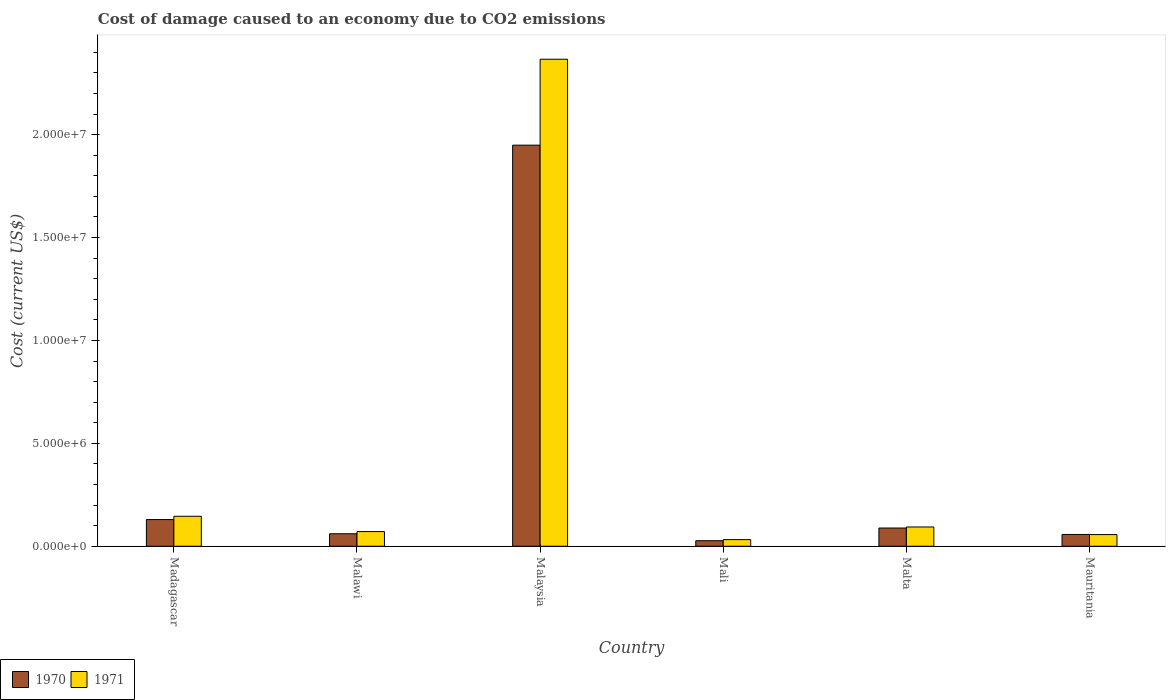How many groups of bars are there?
Ensure brevity in your answer.  6. Are the number of bars on each tick of the X-axis equal?
Your answer should be very brief. Yes. What is the label of the 5th group of bars from the left?
Your answer should be compact. Malta. In how many cases, is the number of bars for a given country not equal to the number of legend labels?
Provide a short and direct response. 0. What is the cost of damage caused due to CO2 emissisons in 1971 in Mali?
Offer a terse response. 3.23e+05. Across all countries, what is the maximum cost of damage caused due to CO2 emissisons in 1970?
Your response must be concise. 1.95e+07. Across all countries, what is the minimum cost of damage caused due to CO2 emissisons in 1970?
Ensure brevity in your answer.  2.69e+05. In which country was the cost of damage caused due to CO2 emissisons in 1971 maximum?
Ensure brevity in your answer.  Malaysia. In which country was the cost of damage caused due to CO2 emissisons in 1971 minimum?
Ensure brevity in your answer.  Mali. What is the total cost of damage caused due to CO2 emissisons in 1970 in the graph?
Ensure brevity in your answer.  2.31e+07. What is the difference between the cost of damage caused due to CO2 emissisons in 1970 in Madagascar and that in Mali?
Provide a short and direct response. 1.03e+06. What is the difference between the cost of damage caused due to CO2 emissisons in 1970 in Mauritania and the cost of damage caused due to CO2 emissisons in 1971 in Madagascar?
Make the answer very short. -8.84e+05. What is the average cost of damage caused due to CO2 emissisons in 1971 per country?
Your response must be concise. 4.61e+06. What is the difference between the cost of damage caused due to CO2 emissisons of/in 1971 and cost of damage caused due to CO2 emissisons of/in 1970 in Malta?
Provide a short and direct response. 5.07e+04. In how many countries, is the cost of damage caused due to CO2 emissisons in 1971 greater than 5000000 US$?
Give a very brief answer. 1. What is the ratio of the cost of damage caused due to CO2 emissisons in 1971 in Malawi to that in Malaysia?
Your response must be concise. 0.03. Is the cost of damage caused due to CO2 emissisons in 1970 in Malawi less than that in Mali?
Your response must be concise. No. Is the difference between the cost of damage caused due to CO2 emissisons in 1971 in Malaysia and Mauritania greater than the difference between the cost of damage caused due to CO2 emissisons in 1970 in Malaysia and Mauritania?
Provide a succinct answer. Yes. What is the difference between the highest and the second highest cost of damage caused due to CO2 emissisons in 1971?
Make the answer very short. -2.22e+07. What is the difference between the highest and the lowest cost of damage caused due to CO2 emissisons in 1970?
Your response must be concise. 1.92e+07. In how many countries, is the cost of damage caused due to CO2 emissisons in 1971 greater than the average cost of damage caused due to CO2 emissisons in 1971 taken over all countries?
Ensure brevity in your answer.  1. Is the sum of the cost of damage caused due to CO2 emissisons in 1971 in Mali and Malta greater than the maximum cost of damage caused due to CO2 emissisons in 1970 across all countries?
Your answer should be very brief. No. What does the 2nd bar from the left in Mauritania represents?
Provide a short and direct response. 1971. How many countries are there in the graph?
Give a very brief answer. 6. Are the values on the major ticks of Y-axis written in scientific E-notation?
Keep it short and to the point. Yes. Does the graph contain any zero values?
Offer a very short reply. No. How many legend labels are there?
Give a very brief answer. 2. How are the legend labels stacked?
Your answer should be very brief. Horizontal. What is the title of the graph?
Your answer should be compact. Cost of damage caused to an economy due to CO2 emissions. What is the label or title of the X-axis?
Your answer should be compact. Country. What is the label or title of the Y-axis?
Offer a very short reply. Cost (current US$). What is the Cost (current US$) in 1970 in Madagascar?
Give a very brief answer. 1.30e+06. What is the Cost (current US$) in 1971 in Madagascar?
Your answer should be compact. 1.46e+06. What is the Cost (current US$) in 1970 in Malawi?
Your response must be concise. 6.07e+05. What is the Cost (current US$) of 1971 in Malawi?
Your answer should be compact. 7.13e+05. What is the Cost (current US$) in 1970 in Malaysia?
Offer a very short reply. 1.95e+07. What is the Cost (current US$) of 1971 in Malaysia?
Keep it short and to the point. 2.37e+07. What is the Cost (current US$) in 1970 in Mali?
Offer a very short reply. 2.69e+05. What is the Cost (current US$) of 1971 in Mali?
Your answer should be very brief. 3.23e+05. What is the Cost (current US$) of 1970 in Malta?
Your answer should be very brief. 8.86e+05. What is the Cost (current US$) of 1971 in Malta?
Your answer should be very brief. 9.37e+05. What is the Cost (current US$) in 1970 in Mauritania?
Ensure brevity in your answer.  5.73e+05. What is the Cost (current US$) of 1971 in Mauritania?
Your answer should be compact. 5.67e+05. Across all countries, what is the maximum Cost (current US$) in 1970?
Your answer should be compact. 1.95e+07. Across all countries, what is the maximum Cost (current US$) in 1971?
Your answer should be very brief. 2.37e+07. Across all countries, what is the minimum Cost (current US$) of 1970?
Your response must be concise. 2.69e+05. Across all countries, what is the minimum Cost (current US$) of 1971?
Make the answer very short. 3.23e+05. What is the total Cost (current US$) of 1970 in the graph?
Offer a very short reply. 2.31e+07. What is the total Cost (current US$) in 1971 in the graph?
Your answer should be compact. 2.77e+07. What is the difference between the Cost (current US$) of 1970 in Madagascar and that in Malawi?
Your answer should be compact. 6.90e+05. What is the difference between the Cost (current US$) in 1971 in Madagascar and that in Malawi?
Provide a succinct answer. 7.44e+05. What is the difference between the Cost (current US$) of 1970 in Madagascar and that in Malaysia?
Make the answer very short. -1.82e+07. What is the difference between the Cost (current US$) in 1971 in Madagascar and that in Malaysia?
Your answer should be compact. -2.22e+07. What is the difference between the Cost (current US$) in 1970 in Madagascar and that in Mali?
Your answer should be very brief. 1.03e+06. What is the difference between the Cost (current US$) in 1971 in Madagascar and that in Mali?
Give a very brief answer. 1.13e+06. What is the difference between the Cost (current US$) of 1970 in Madagascar and that in Malta?
Keep it short and to the point. 4.11e+05. What is the difference between the Cost (current US$) in 1971 in Madagascar and that in Malta?
Provide a short and direct response. 5.20e+05. What is the difference between the Cost (current US$) of 1970 in Madagascar and that in Mauritania?
Give a very brief answer. 7.24e+05. What is the difference between the Cost (current US$) in 1971 in Madagascar and that in Mauritania?
Offer a very short reply. 8.90e+05. What is the difference between the Cost (current US$) in 1970 in Malawi and that in Malaysia?
Offer a very short reply. -1.89e+07. What is the difference between the Cost (current US$) in 1971 in Malawi and that in Malaysia?
Offer a very short reply. -2.30e+07. What is the difference between the Cost (current US$) of 1970 in Malawi and that in Mali?
Keep it short and to the point. 3.38e+05. What is the difference between the Cost (current US$) of 1971 in Malawi and that in Mali?
Provide a short and direct response. 3.90e+05. What is the difference between the Cost (current US$) of 1970 in Malawi and that in Malta?
Offer a very short reply. -2.79e+05. What is the difference between the Cost (current US$) in 1971 in Malawi and that in Malta?
Your response must be concise. -2.24e+05. What is the difference between the Cost (current US$) in 1970 in Malawi and that in Mauritania?
Give a very brief answer. 3.43e+04. What is the difference between the Cost (current US$) of 1971 in Malawi and that in Mauritania?
Provide a succinct answer. 1.46e+05. What is the difference between the Cost (current US$) of 1970 in Malaysia and that in Mali?
Offer a terse response. 1.92e+07. What is the difference between the Cost (current US$) in 1971 in Malaysia and that in Mali?
Your answer should be compact. 2.33e+07. What is the difference between the Cost (current US$) in 1970 in Malaysia and that in Malta?
Offer a very short reply. 1.86e+07. What is the difference between the Cost (current US$) of 1971 in Malaysia and that in Malta?
Keep it short and to the point. 2.27e+07. What is the difference between the Cost (current US$) in 1970 in Malaysia and that in Mauritania?
Offer a terse response. 1.89e+07. What is the difference between the Cost (current US$) in 1971 in Malaysia and that in Mauritania?
Make the answer very short. 2.31e+07. What is the difference between the Cost (current US$) of 1970 in Mali and that in Malta?
Your response must be concise. -6.17e+05. What is the difference between the Cost (current US$) in 1971 in Mali and that in Malta?
Give a very brief answer. -6.14e+05. What is the difference between the Cost (current US$) of 1970 in Mali and that in Mauritania?
Your answer should be very brief. -3.03e+05. What is the difference between the Cost (current US$) of 1971 in Mali and that in Mauritania?
Your answer should be compact. -2.45e+05. What is the difference between the Cost (current US$) in 1970 in Malta and that in Mauritania?
Provide a succinct answer. 3.13e+05. What is the difference between the Cost (current US$) of 1971 in Malta and that in Mauritania?
Offer a very short reply. 3.69e+05. What is the difference between the Cost (current US$) of 1970 in Madagascar and the Cost (current US$) of 1971 in Malawi?
Offer a terse response. 5.84e+05. What is the difference between the Cost (current US$) of 1970 in Madagascar and the Cost (current US$) of 1971 in Malaysia?
Offer a terse response. -2.24e+07. What is the difference between the Cost (current US$) in 1970 in Madagascar and the Cost (current US$) in 1971 in Mali?
Offer a very short reply. 9.74e+05. What is the difference between the Cost (current US$) of 1970 in Madagascar and the Cost (current US$) of 1971 in Malta?
Ensure brevity in your answer.  3.60e+05. What is the difference between the Cost (current US$) of 1970 in Madagascar and the Cost (current US$) of 1971 in Mauritania?
Give a very brief answer. 7.30e+05. What is the difference between the Cost (current US$) of 1970 in Malawi and the Cost (current US$) of 1971 in Malaysia?
Provide a short and direct response. -2.31e+07. What is the difference between the Cost (current US$) in 1970 in Malawi and the Cost (current US$) in 1971 in Mali?
Make the answer very short. 2.84e+05. What is the difference between the Cost (current US$) in 1970 in Malawi and the Cost (current US$) in 1971 in Malta?
Keep it short and to the point. -3.30e+05. What is the difference between the Cost (current US$) of 1970 in Malawi and the Cost (current US$) of 1971 in Mauritania?
Your response must be concise. 3.97e+04. What is the difference between the Cost (current US$) of 1970 in Malaysia and the Cost (current US$) of 1971 in Mali?
Ensure brevity in your answer.  1.92e+07. What is the difference between the Cost (current US$) in 1970 in Malaysia and the Cost (current US$) in 1971 in Malta?
Your answer should be very brief. 1.86e+07. What is the difference between the Cost (current US$) in 1970 in Malaysia and the Cost (current US$) in 1971 in Mauritania?
Provide a short and direct response. 1.89e+07. What is the difference between the Cost (current US$) in 1970 in Mali and the Cost (current US$) in 1971 in Malta?
Make the answer very short. -6.67e+05. What is the difference between the Cost (current US$) in 1970 in Mali and the Cost (current US$) in 1971 in Mauritania?
Keep it short and to the point. -2.98e+05. What is the difference between the Cost (current US$) of 1970 in Malta and the Cost (current US$) of 1971 in Mauritania?
Provide a short and direct response. 3.19e+05. What is the average Cost (current US$) in 1970 per country?
Keep it short and to the point. 3.85e+06. What is the average Cost (current US$) in 1971 per country?
Give a very brief answer. 4.61e+06. What is the difference between the Cost (current US$) of 1970 and Cost (current US$) of 1971 in Madagascar?
Your answer should be very brief. -1.60e+05. What is the difference between the Cost (current US$) in 1970 and Cost (current US$) in 1971 in Malawi?
Ensure brevity in your answer.  -1.06e+05. What is the difference between the Cost (current US$) of 1970 and Cost (current US$) of 1971 in Malaysia?
Ensure brevity in your answer.  -4.18e+06. What is the difference between the Cost (current US$) of 1970 and Cost (current US$) of 1971 in Mali?
Your response must be concise. -5.34e+04. What is the difference between the Cost (current US$) of 1970 and Cost (current US$) of 1971 in Malta?
Your response must be concise. -5.07e+04. What is the difference between the Cost (current US$) in 1970 and Cost (current US$) in 1971 in Mauritania?
Your answer should be very brief. 5478.06. What is the ratio of the Cost (current US$) of 1970 in Madagascar to that in Malawi?
Offer a terse response. 2.14. What is the ratio of the Cost (current US$) in 1971 in Madagascar to that in Malawi?
Give a very brief answer. 2.04. What is the ratio of the Cost (current US$) of 1970 in Madagascar to that in Malaysia?
Provide a short and direct response. 0.07. What is the ratio of the Cost (current US$) in 1971 in Madagascar to that in Malaysia?
Provide a succinct answer. 0.06. What is the ratio of the Cost (current US$) in 1970 in Madagascar to that in Mali?
Your response must be concise. 4.82. What is the ratio of the Cost (current US$) of 1971 in Madagascar to that in Mali?
Make the answer very short. 4.52. What is the ratio of the Cost (current US$) in 1970 in Madagascar to that in Malta?
Give a very brief answer. 1.46. What is the ratio of the Cost (current US$) in 1971 in Madagascar to that in Malta?
Your answer should be very brief. 1.56. What is the ratio of the Cost (current US$) of 1970 in Madagascar to that in Mauritania?
Your response must be concise. 2.27. What is the ratio of the Cost (current US$) in 1971 in Madagascar to that in Mauritania?
Offer a terse response. 2.57. What is the ratio of the Cost (current US$) of 1970 in Malawi to that in Malaysia?
Make the answer very short. 0.03. What is the ratio of the Cost (current US$) of 1971 in Malawi to that in Malaysia?
Provide a short and direct response. 0.03. What is the ratio of the Cost (current US$) of 1970 in Malawi to that in Mali?
Your response must be concise. 2.25. What is the ratio of the Cost (current US$) in 1971 in Malawi to that in Mali?
Your answer should be compact. 2.21. What is the ratio of the Cost (current US$) of 1970 in Malawi to that in Malta?
Provide a short and direct response. 0.69. What is the ratio of the Cost (current US$) in 1971 in Malawi to that in Malta?
Your response must be concise. 0.76. What is the ratio of the Cost (current US$) of 1970 in Malawi to that in Mauritania?
Ensure brevity in your answer.  1.06. What is the ratio of the Cost (current US$) of 1971 in Malawi to that in Mauritania?
Provide a succinct answer. 1.26. What is the ratio of the Cost (current US$) in 1970 in Malaysia to that in Mali?
Give a very brief answer. 72.4. What is the ratio of the Cost (current US$) of 1971 in Malaysia to that in Mali?
Your response must be concise. 73.35. What is the ratio of the Cost (current US$) of 1970 in Malaysia to that in Malta?
Give a very brief answer. 22. What is the ratio of the Cost (current US$) of 1971 in Malaysia to that in Malta?
Offer a terse response. 25.27. What is the ratio of the Cost (current US$) of 1970 in Malaysia to that in Mauritania?
Give a very brief answer. 34.03. What is the ratio of the Cost (current US$) in 1971 in Malaysia to that in Mauritania?
Your answer should be very brief. 41.72. What is the ratio of the Cost (current US$) in 1970 in Mali to that in Malta?
Offer a terse response. 0.3. What is the ratio of the Cost (current US$) in 1971 in Mali to that in Malta?
Provide a short and direct response. 0.34. What is the ratio of the Cost (current US$) of 1970 in Mali to that in Mauritania?
Ensure brevity in your answer.  0.47. What is the ratio of the Cost (current US$) in 1971 in Mali to that in Mauritania?
Your response must be concise. 0.57. What is the ratio of the Cost (current US$) in 1970 in Malta to that in Mauritania?
Ensure brevity in your answer.  1.55. What is the ratio of the Cost (current US$) of 1971 in Malta to that in Mauritania?
Ensure brevity in your answer.  1.65. What is the difference between the highest and the second highest Cost (current US$) in 1970?
Give a very brief answer. 1.82e+07. What is the difference between the highest and the second highest Cost (current US$) in 1971?
Your answer should be compact. 2.22e+07. What is the difference between the highest and the lowest Cost (current US$) of 1970?
Your answer should be very brief. 1.92e+07. What is the difference between the highest and the lowest Cost (current US$) in 1971?
Offer a very short reply. 2.33e+07. 